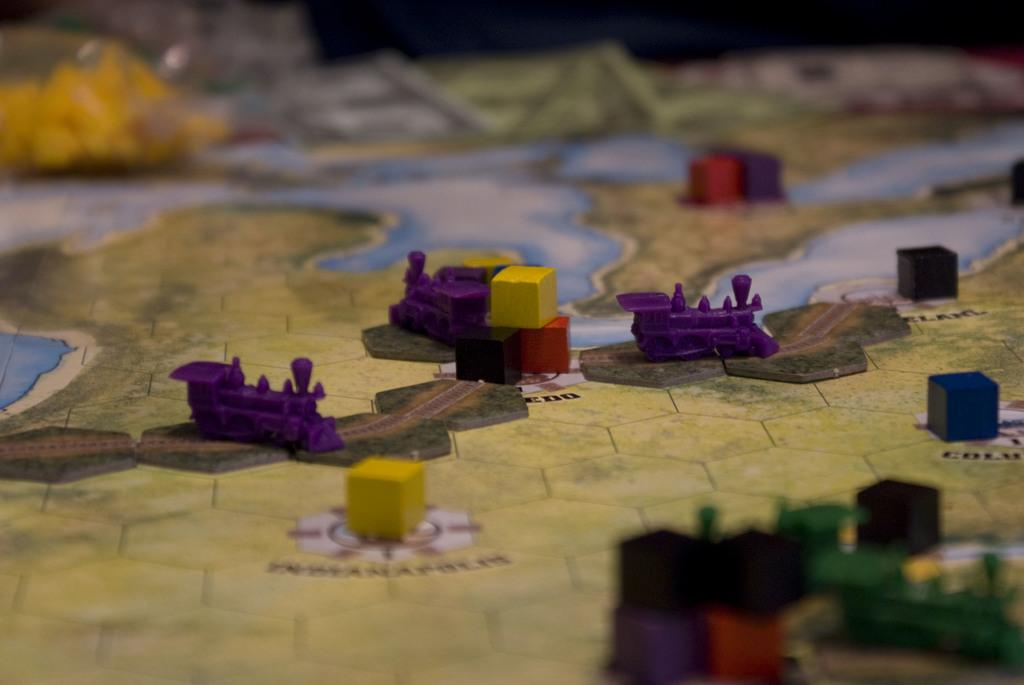What type of toys are present in the image? There are toy trains in the image. What other objects can be seen in the image? There are blocks in the image. On what surface are the toys and blocks placed? The objects are placed on a map. What grade level is the prose written in the image? There is no prose present in the image, as it features toy trains, blocks, and a map. 